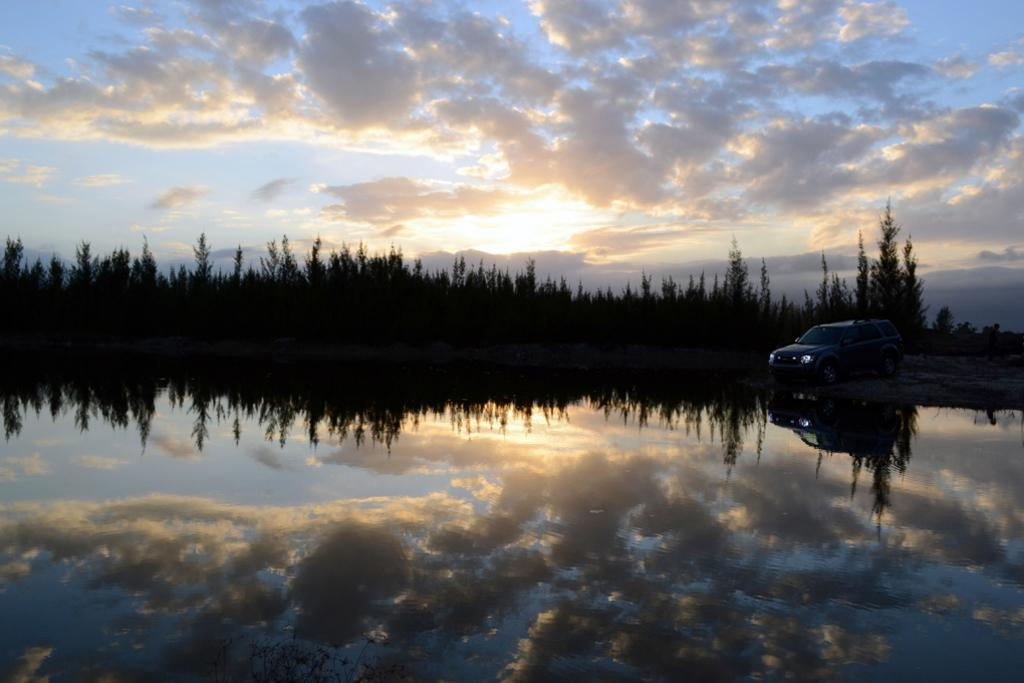What is the primary element visible in the image? There is water in the image. What type of vehicle can be seen in the image? There is a car in the image. What can be seen in the background of the image? There are trees and the sky visible in the background of the image. What type of cakes are being served as punishment in the image? There are no cakes or any indication of punishment present in the image. 